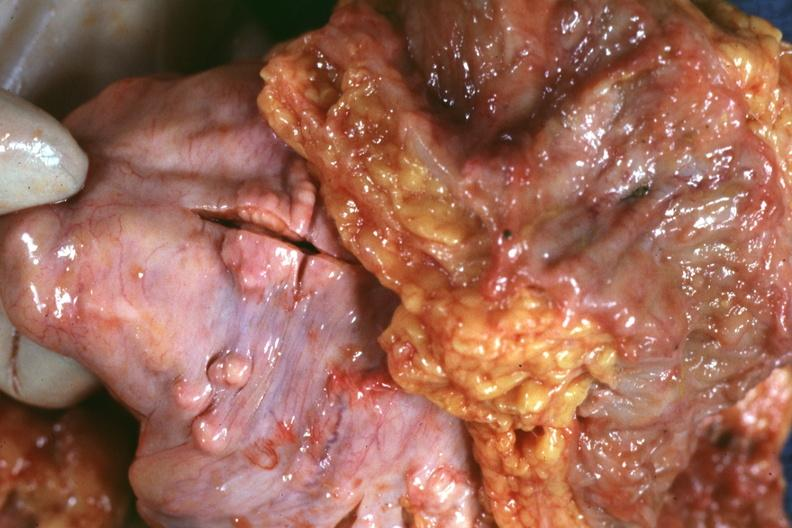what does this image show?
Answer the question using a single word or phrase. View of rectovesical pouch with obvious tumor nodules beneath peritoneum very good example 